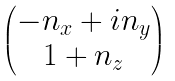<formula> <loc_0><loc_0><loc_500><loc_500>\begin{pmatrix} - n _ { x } + i n _ { y } \\ 1 + n _ { z } \end{pmatrix}</formula> 